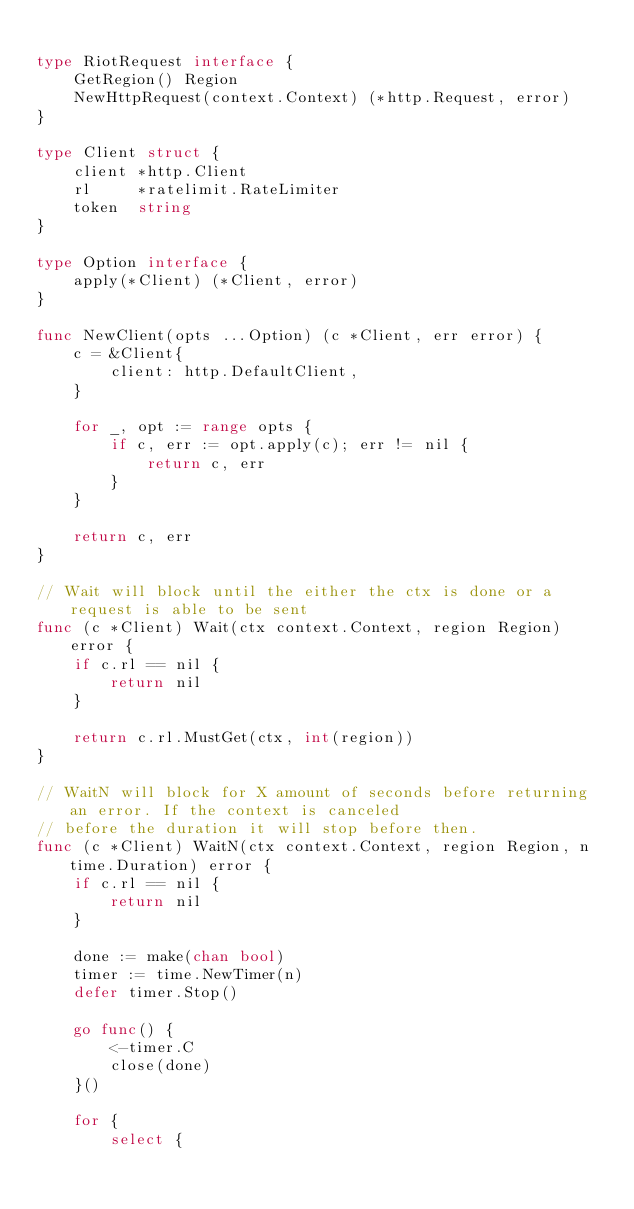<code> <loc_0><loc_0><loc_500><loc_500><_Go_>
type RiotRequest interface {
	GetRegion() Region
	NewHttpRequest(context.Context) (*http.Request, error)
}

type Client struct {
	client *http.Client
	rl     *ratelimit.RateLimiter
	token  string
}

type Option interface {
	apply(*Client) (*Client, error)
}

func NewClient(opts ...Option) (c *Client, err error) {
	c = &Client{
		client: http.DefaultClient,
	}

	for _, opt := range opts {
		if c, err := opt.apply(c); err != nil {
			return c, err
		}
	}

	return c, err
}

// Wait will block until the either the ctx is done or a request is able to be sent
func (c *Client) Wait(ctx context.Context, region Region) error {
	if c.rl == nil {
		return nil
	}

	return c.rl.MustGet(ctx, int(region))
}

// WaitN will block for X amount of seconds before returning an error. If the context is canceled
// before the duration it will stop before then.
func (c *Client) WaitN(ctx context.Context, region Region, n time.Duration) error {
	if c.rl == nil {
		return nil
	}

	done := make(chan bool)
	timer := time.NewTimer(n)
	defer timer.Stop()

	go func() {
		<-timer.C
		close(done)
	}()

	for {
		select {</code> 